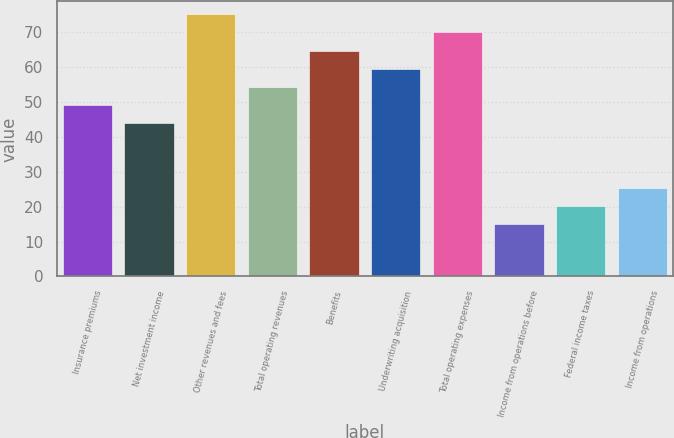Convert chart to OTSL. <chart><loc_0><loc_0><loc_500><loc_500><bar_chart><fcel>Insurance premiums<fcel>Net investment income<fcel>Other revenues and fees<fcel>Total operating revenues<fcel>Benefits<fcel>Underwriting acquisition<fcel>Total operating expenses<fcel>Income from operations before<fcel>Federal income taxes<fcel>Income from operations<nl><fcel>49.2<fcel>44<fcel>75.2<fcel>54.4<fcel>64.8<fcel>59.6<fcel>70<fcel>15<fcel>20.2<fcel>25.4<nl></chart> 